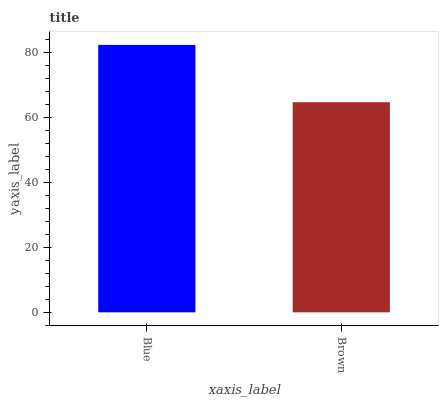Is Brown the minimum?
Answer yes or no. Yes. Is Blue the maximum?
Answer yes or no. Yes. Is Brown the maximum?
Answer yes or no. No. Is Blue greater than Brown?
Answer yes or no. Yes. Is Brown less than Blue?
Answer yes or no. Yes. Is Brown greater than Blue?
Answer yes or no. No. Is Blue less than Brown?
Answer yes or no. No. Is Blue the high median?
Answer yes or no. Yes. Is Brown the low median?
Answer yes or no. Yes. Is Brown the high median?
Answer yes or no. No. Is Blue the low median?
Answer yes or no. No. 